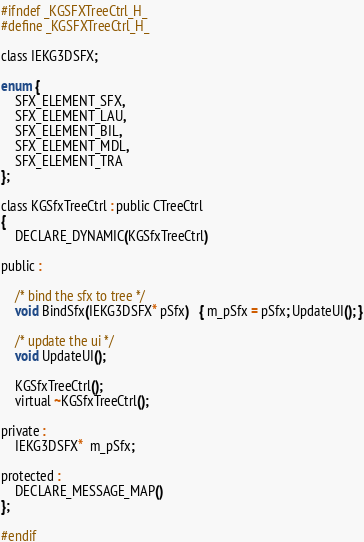<code> <loc_0><loc_0><loc_500><loc_500><_C_>

#ifndef _KGSFXTreeCtrl_H_
#define _KGSFXTreeCtrl_H_

class IEKG3DSFX;

enum {
    SFX_ELEMENT_SFX,
    SFX_ELEMENT_LAU,
    SFX_ELEMENT_BIL,
    SFX_ELEMENT_MDL,
    SFX_ELEMENT_TRA
};

class KGSfxTreeCtrl : public CTreeCtrl
{
	DECLARE_DYNAMIC(KGSfxTreeCtrl)

public :

    /* bind the sfx to tree */
    void BindSfx(IEKG3DSFX* pSfx)   { m_pSfx = pSfx; UpdateUI(); }
    
    /* update the ui */
    void UpdateUI();

	KGSfxTreeCtrl();
	virtual ~KGSfxTreeCtrl();

private :
    IEKG3DSFX*  m_pSfx;

protected :
	DECLARE_MESSAGE_MAP()
};

#endif
</code> 